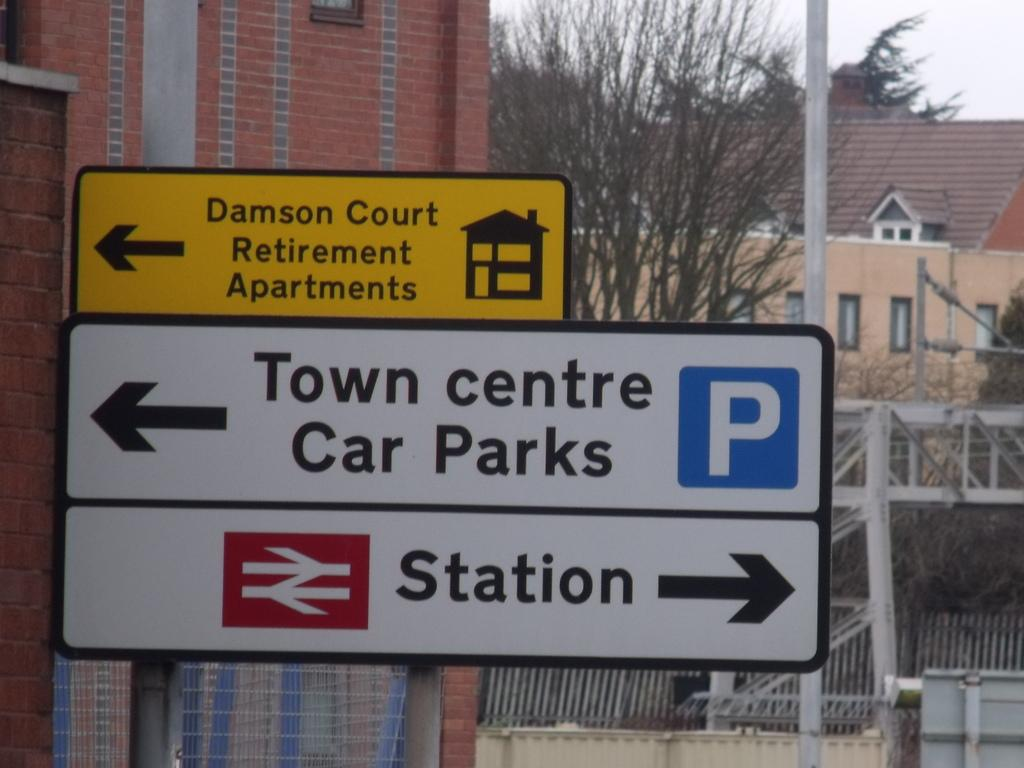Provide a one-sentence caption for the provided image. The street sign for Town Center Car Parks and the Station is shown in closeup with a background of buildings. 